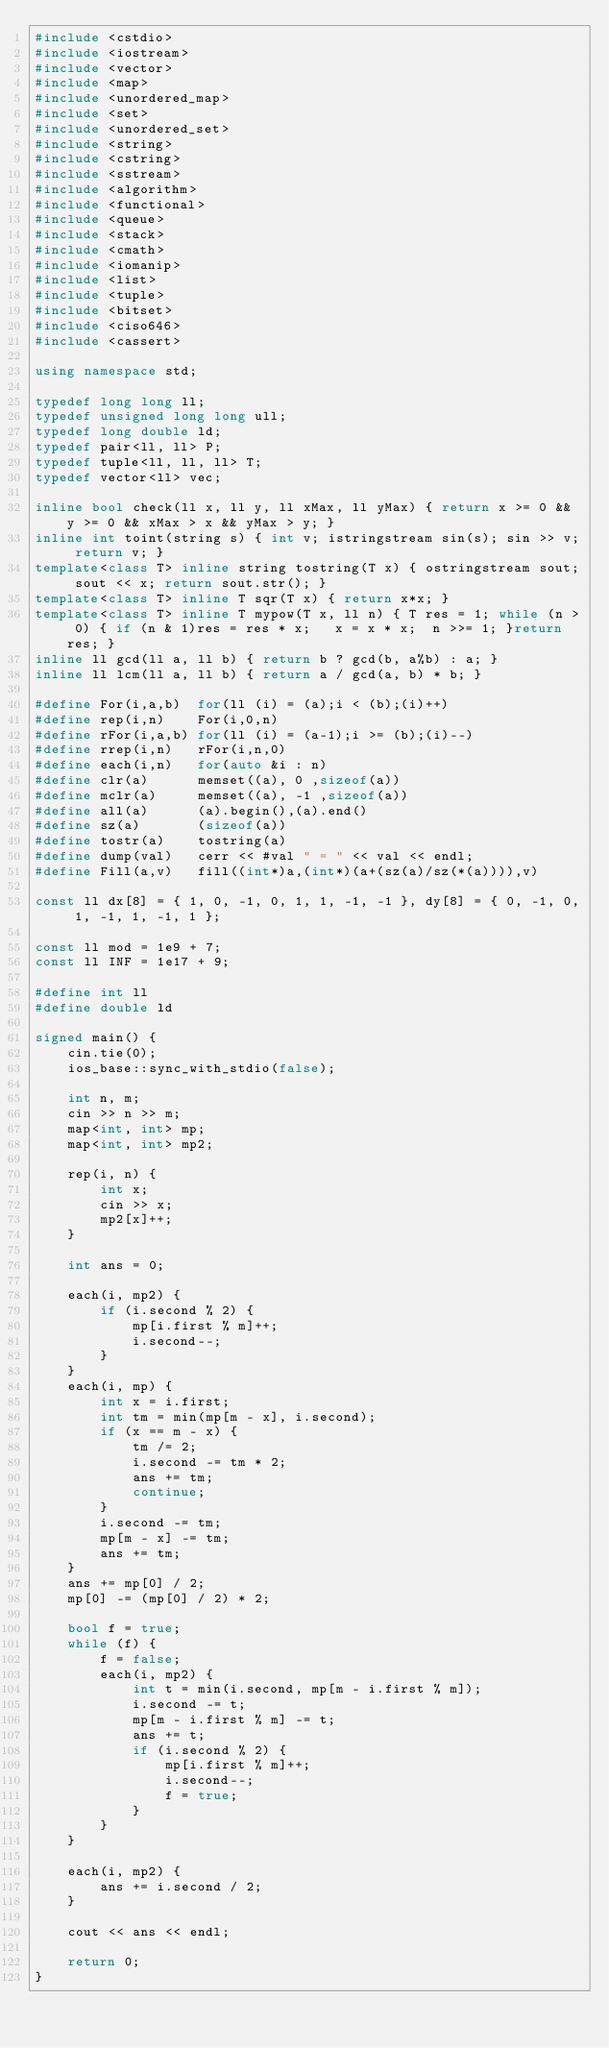Convert code to text. <code><loc_0><loc_0><loc_500><loc_500><_C++_>#include <cstdio>
#include <iostream>
#include <vector>
#include <map>
#include <unordered_map>
#include <set>
#include <unordered_set>
#include <string>
#include <cstring>
#include <sstream>
#include <algorithm>
#include <functional>
#include <queue>
#include <stack>
#include <cmath>
#include <iomanip>
#include <list>
#include <tuple>
#include <bitset>
#include <ciso646>
#include <cassert>

using namespace std;

typedef long long ll;
typedef unsigned long long ull;
typedef long double ld;
typedef pair<ll, ll> P;
typedef tuple<ll, ll, ll> T;
typedef vector<ll> vec;

inline bool check(ll x, ll y, ll xMax, ll yMax) { return x >= 0 && y >= 0 && xMax > x && yMax > y; }
inline int toint(string s) { int v; istringstream sin(s); sin >> v; return v; }
template<class T> inline string tostring(T x) { ostringstream sout; sout << x; return sout.str(); }
template<class T> inline T sqr(T x) { return x*x; }
template<class T> inline T mypow(T x, ll n) { T res = 1; while (n > 0) { if (n & 1)res = res * x;	x = x * x;	n >>= 1; }return res; }
inline ll gcd(ll a, ll b) { return b ? gcd(b, a%b) : a; }
inline ll lcm(ll a, ll b) { return a / gcd(a, b) * b; }

#define For(i,a,b)	for(ll (i) = (a);i < (b);(i)++)
#define rep(i,n)	For(i,0,n)
#define rFor(i,a,b)	for(ll (i) = (a-1);i >= (b);(i)--)
#define rrep(i,n)	rFor(i,n,0)
#define each(i,n)	for(auto &i : n)
#define clr(a)		memset((a), 0 ,sizeof(a))
#define mclr(a)		memset((a), -1 ,sizeof(a))
#define all(a)		(a).begin(),(a).end()
#define sz(a)		(sizeof(a))
#define tostr(a)	tostring(a)
#define dump(val) 	cerr << #val " = " << val << endl;
#define Fill(a,v)	fill((int*)a,(int*)(a+(sz(a)/sz(*(a)))),v)

const ll dx[8] = { 1, 0, -1, 0, 1, 1, -1, -1 }, dy[8] = { 0, -1, 0, 1, -1, 1, -1, 1 };

const ll mod = 1e9 + 7;
const ll INF = 1e17 + 9;

#define int ll
#define double ld

signed main() {
	cin.tie(0);
	ios_base::sync_with_stdio(false);

	int n, m;
	cin >> n >> m;
	map<int, int> mp;
	map<int, int> mp2;

	rep(i, n) {
		int x;
		cin >> x;
		mp2[x]++;
	}

	int ans = 0;

	each(i, mp2) {
		if (i.second % 2) {
			mp[i.first % m]++;
			i.second--;
		}
	}
	each(i, mp) {
		int x = i.first;
		int tm = min(mp[m - x], i.second);
		if (x == m - x) {
			tm /= 2;
			i.second -= tm * 2;
			ans += tm;
			continue;
		}
		i.second -= tm;
		mp[m - x] -= tm;
		ans += tm;
	}
	ans += mp[0] / 2;
	mp[0] -= (mp[0] / 2) * 2;

	bool f = true;
	while (f) {
		f = false;
		each(i, mp2) {
			int t = min(i.second, mp[m - i.first % m]);
			i.second -= t;
			mp[m - i.first % m] -= t;
			ans += t;
			if (i.second % 2) {
				mp[i.first % m]++;
				i.second--;
				f = true;
			}
		}
	}

	each(i, mp2) {
		ans += i.second / 2;
	}

	cout << ans << endl;

	return 0;
}</code> 